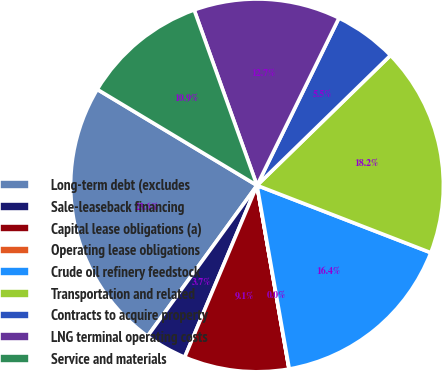<chart> <loc_0><loc_0><loc_500><loc_500><pie_chart><fcel>Long-term debt (excludes<fcel>Sale-leaseback financing<fcel>Capital lease obligations (a)<fcel>Operating lease obligations<fcel>Crude oil refinery feedstock<fcel>Transportation and related<fcel>Contracts to acquire property<fcel>LNG terminal operating costs<fcel>Service and materials<nl><fcel>23.62%<fcel>3.65%<fcel>9.09%<fcel>0.02%<fcel>16.35%<fcel>18.17%<fcel>5.46%<fcel>12.72%<fcel>10.91%<nl></chart> 